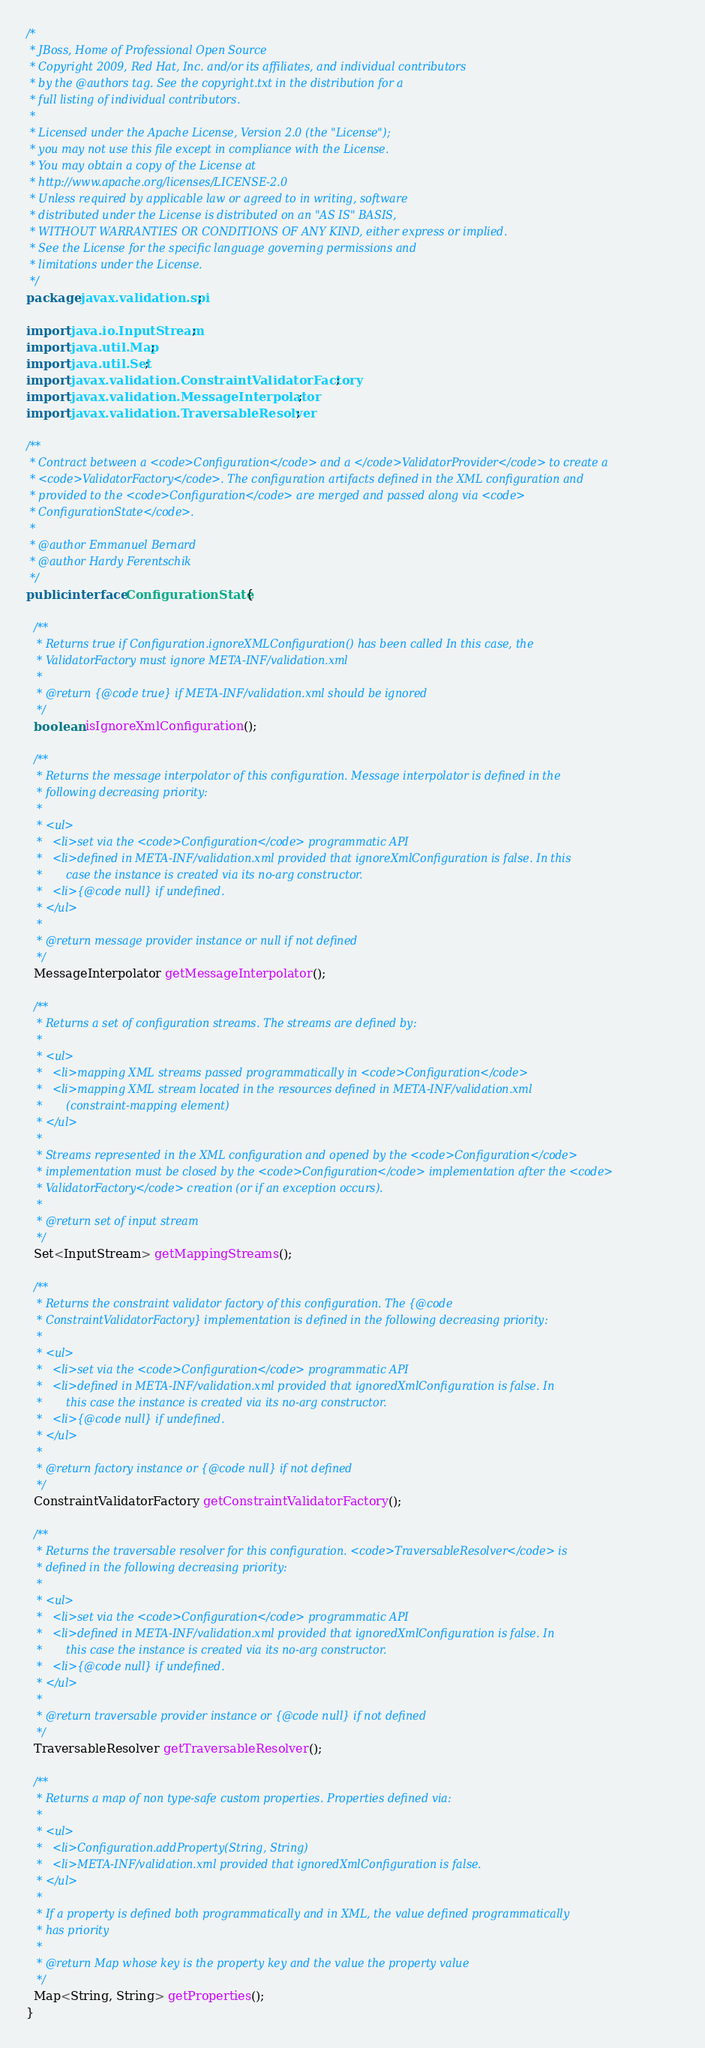Convert code to text. <code><loc_0><loc_0><loc_500><loc_500><_Java_>/*
 * JBoss, Home of Professional Open Source
 * Copyright 2009, Red Hat, Inc. and/or its affiliates, and individual contributors
 * by the @authors tag. See the copyright.txt in the distribution for a
 * full listing of individual contributors.
 *
 * Licensed under the Apache License, Version 2.0 (the "License");
 * you may not use this file except in compliance with the License.
 * You may obtain a copy of the License at
 * http://www.apache.org/licenses/LICENSE-2.0
 * Unless required by applicable law or agreed to in writing, software
 * distributed under the License is distributed on an "AS IS" BASIS,
 * WITHOUT WARRANTIES OR CONDITIONS OF ANY KIND, either express or implied.
 * See the License for the specific language governing permissions and
 * limitations under the License.
 */
package javax.validation.spi;

import java.io.InputStream;
import java.util.Map;
import java.util.Set;
import javax.validation.ConstraintValidatorFactory;
import javax.validation.MessageInterpolator;
import javax.validation.TraversableResolver;

/**
 * Contract between a <code>Configuration</code> and a </code>ValidatorProvider</code> to create a
 * <code>ValidatorFactory</code>. The configuration artifacts defined in the XML configuration and
 * provided to the <code>Configuration</code> are merged and passed along via <code>
 * ConfigurationState</code>.
 *
 * @author Emmanuel Bernard
 * @author Hardy Ferentschik
 */
public interface ConfigurationState {

  /**
   * Returns true if Configuration.ignoreXMLConfiguration() has been called In this case, the
   * ValidatorFactory must ignore META-INF/validation.xml
   *
   * @return {@code true} if META-INF/validation.xml should be ignored
   */
  boolean isIgnoreXmlConfiguration();

  /**
   * Returns the message interpolator of this configuration. Message interpolator is defined in the
   * following decreasing priority:
   *
   * <ul>
   *   <li>set via the <code>Configuration</code> programmatic API
   *   <li>defined in META-INF/validation.xml provided that ignoreXmlConfiguration is false. In this
   *       case the instance is created via its no-arg constructor.
   *   <li>{@code null} if undefined.
   * </ul>
   *
   * @return message provider instance or null if not defined
   */
  MessageInterpolator getMessageInterpolator();

  /**
   * Returns a set of configuration streams. The streams are defined by:
   *
   * <ul>
   *   <li>mapping XML streams passed programmatically in <code>Configuration</code>
   *   <li>mapping XML stream located in the resources defined in META-INF/validation.xml
   *       (constraint-mapping element)
   * </ul>
   *
   * Streams represented in the XML configuration and opened by the <code>Configuration</code>
   * implementation must be closed by the <code>Configuration</code> implementation after the <code>
   * ValidatorFactory</code> creation (or if an exception occurs).
   *
   * @return set of input stream
   */
  Set<InputStream> getMappingStreams();

  /**
   * Returns the constraint validator factory of this configuration. The {@code
   * ConstraintValidatorFactory} implementation is defined in the following decreasing priority:
   *
   * <ul>
   *   <li>set via the <code>Configuration</code> programmatic API
   *   <li>defined in META-INF/validation.xml provided that ignoredXmlConfiguration is false. In
   *       this case the instance is created via its no-arg constructor.
   *   <li>{@code null} if undefined.
   * </ul>
   *
   * @return factory instance or {@code null} if not defined
   */
  ConstraintValidatorFactory getConstraintValidatorFactory();

  /**
   * Returns the traversable resolver for this configuration. <code>TraversableResolver</code> is
   * defined in the following decreasing priority:
   *
   * <ul>
   *   <li>set via the <code>Configuration</code> programmatic API
   *   <li>defined in META-INF/validation.xml provided that ignoredXmlConfiguration is false. In
   *       this case the instance is created via its no-arg constructor.
   *   <li>{@code null} if undefined.
   * </ul>
   *
   * @return traversable provider instance or {@code null} if not defined
   */
  TraversableResolver getTraversableResolver();

  /**
   * Returns a map of non type-safe custom properties. Properties defined via:
   *
   * <ul>
   *   <li>Configuration.addProperty(String, String)
   *   <li>META-INF/validation.xml provided that ignoredXmlConfiguration is false.
   * </ul>
   *
   * If a property is defined both programmatically and in XML, the value defined programmatically
   * has priority
   *
   * @return Map whose key is the property key and the value the property value
   */
  Map<String, String> getProperties();
}
</code> 